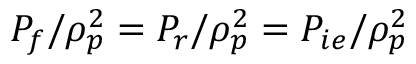<formula> <loc_0><loc_0><loc_500><loc_500>P _ { f } / \rho _ { p } ^ { 2 } = P _ { r } / \rho _ { p } ^ { 2 } = P _ { i e } / \rho _ { p } ^ { 2 }</formula> 